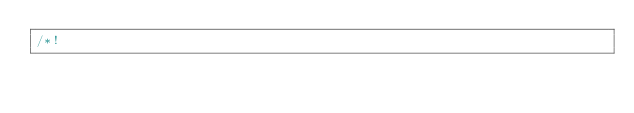Convert code to text. <code><loc_0><loc_0><loc_500><loc_500><_CSS_>/*!</code> 